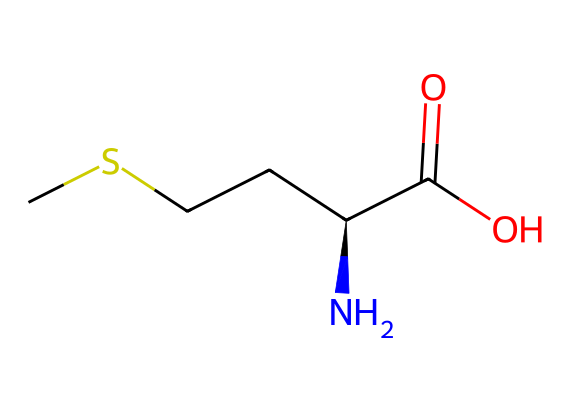What is the molecular formula of methionine? Count the atoms in the SMILES representation: 1 carbon in the methyl group (C), 2 additional carbons from the backbone (C, C), 1 nitrogen (N), 2 oxygens (O), and 5 total hydrogens (H) from bonding. This gives a total molecular formula of C5H11NO2S.
Answer: C5H11NO2S How many chiral centers are present in methionine? Analyze the structure for chiral centers. A chiral center is a carbon atom bonded to four different groups. In the SMILES provided, there is one chiral carbon (the one connected to N, C, carboxyl group, and the sulfur) indicating one chiral center.
Answer: 1 What functional groups are present in methionine? Look at the structure for various functional groups defined by certain atom arrangements. Methionine contains an amino group (NH2), a carboxylic acid group (–COOH), and a thioether group (–S–) in the structure. These clearly define the functional groups present.
Answer: amino, carboxylic acid, thioether What atom is responsible for the sulfur content in methionine? Identify the atom in the SMILES representation that signifies sulfur. In the provided structure, there is an “S” character which directly points to the inclusion of sulfur. Therefore, the part contributing to the sulfur is indicated by "S".
Answer: S What type of chemical is methionine classified as? Understand the classification based on its components: methionine is an organosulfur amino acid due to the presence of both an amino group and a sulfur atom in its structure. The combination of these characteristics leads to its classification.
Answer: organosulfur amino acid How many total hydrogen atoms does methionine contain? Tally the hydrogen atoms associated with each part of the molecule. The SMILES shows that there are five hydrogen atoms attached to the carbon and nitrogen atoms. Including their bonding scenarios, the total adds up to 11 hydrogens.
Answer: 11 What is the role of the sulfur in methionine? Consider the function of sulfur in the structure. The sulfur in methionine is critical for the formation of disulfide bonds in proteins, which are essential for the protein structure's stability and functionality.
Answer: disulfide bonds 